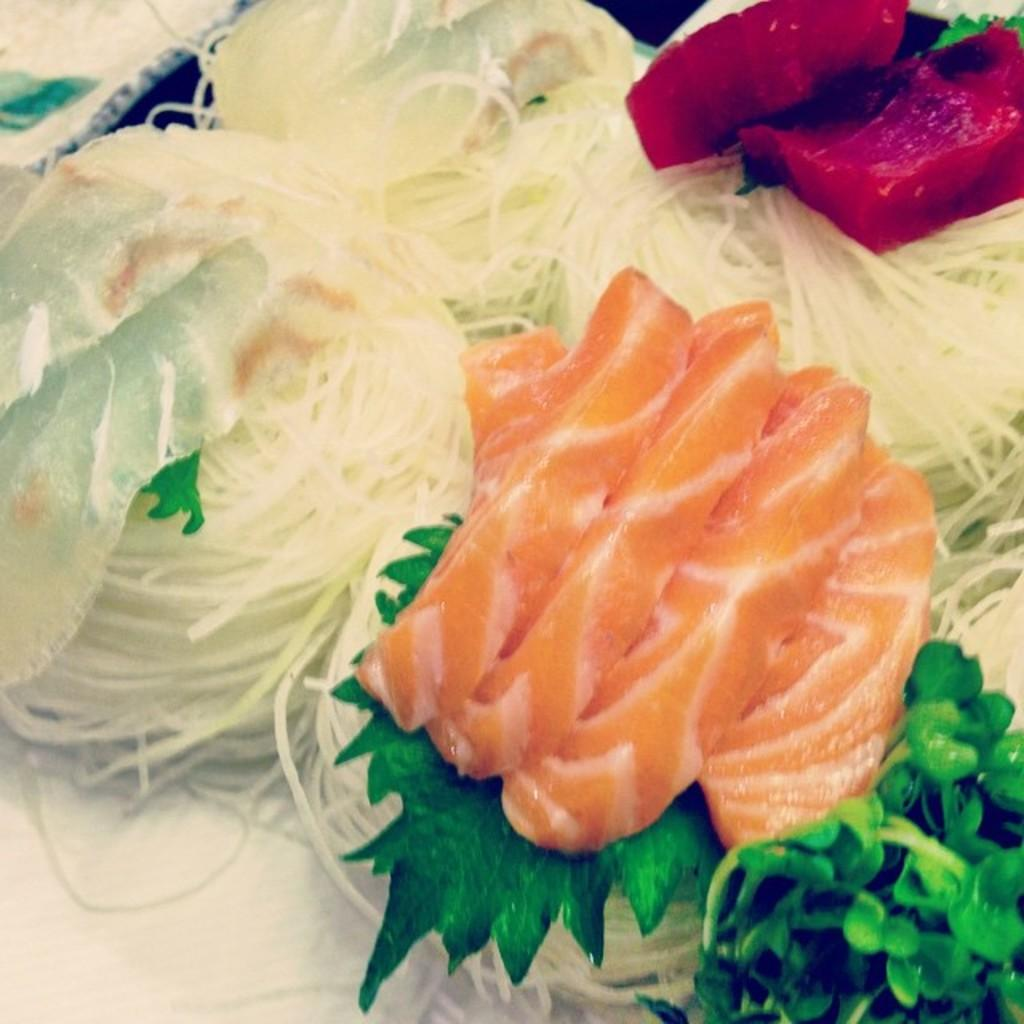What type of food item can be seen in the image? There is a food item in the image, but the specific type cannot be determined from the provided facts. What is located at the bottom of the image? There is tissue at the bottom of the image. What type of boot is visible in the image? There is no boot present in the image. What type of stove is used to cook the food item in the image? There is no stove present in the image, and the specific type of food item cannot be determined from the provided facts. 